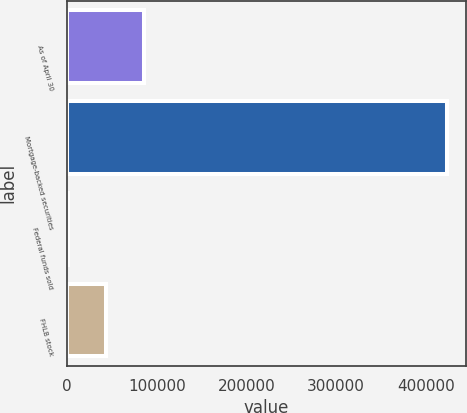Convert chart. <chart><loc_0><loc_0><loc_500><loc_500><bar_chart><fcel>As of April 30<fcel>Mortgage-backed securities<fcel>Federal funds sold<fcel>FHLB stock<nl><fcel>85623.8<fcel>423495<fcel>1156<fcel>43389.9<nl></chart> 